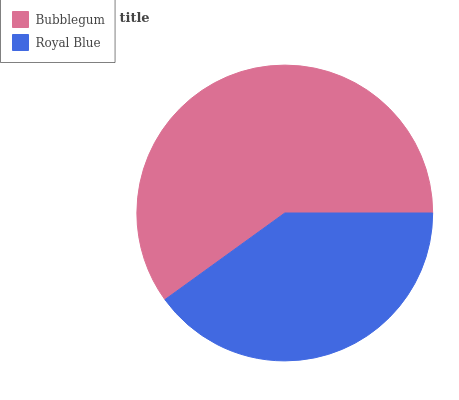Is Royal Blue the minimum?
Answer yes or no. Yes. Is Bubblegum the maximum?
Answer yes or no. Yes. Is Royal Blue the maximum?
Answer yes or no. No. Is Bubblegum greater than Royal Blue?
Answer yes or no. Yes. Is Royal Blue less than Bubblegum?
Answer yes or no. Yes. Is Royal Blue greater than Bubblegum?
Answer yes or no. No. Is Bubblegum less than Royal Blue?
Answer yes or no. No. Is Bubblegum the high median?
Answer yes or no. Yes. Is Royal Blue the low median?
Answer yes or no. Yes. Is Royal Blue the high median?
Answer yes or no. No. Is Bubblegum the low median?
Answer yes or no. No. 